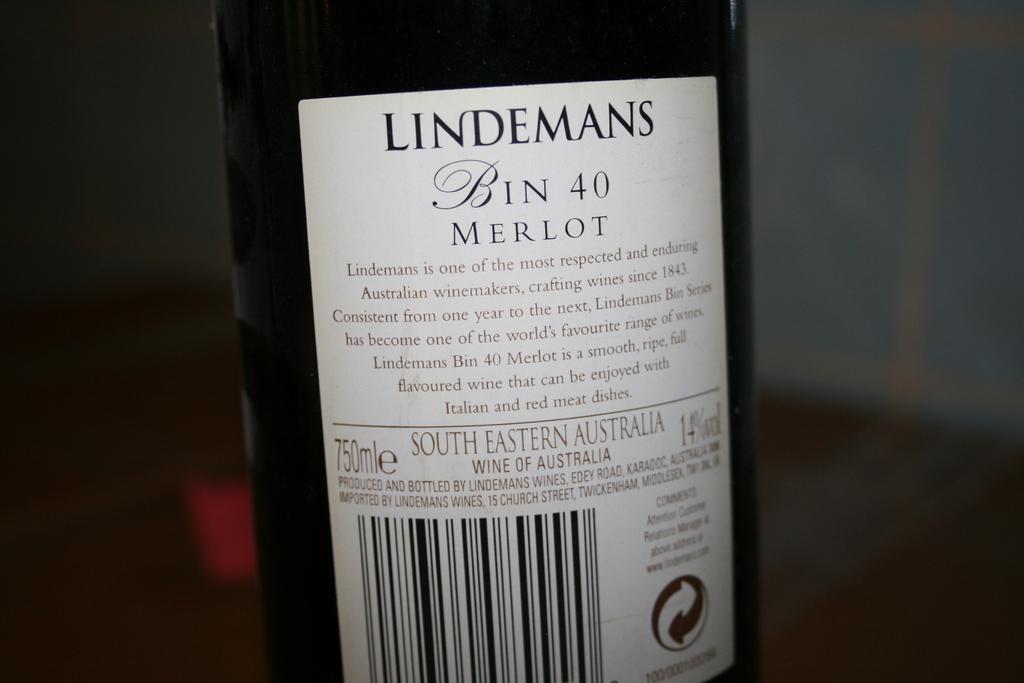What number is on the bottle?
Offer a very short reply. 40. 